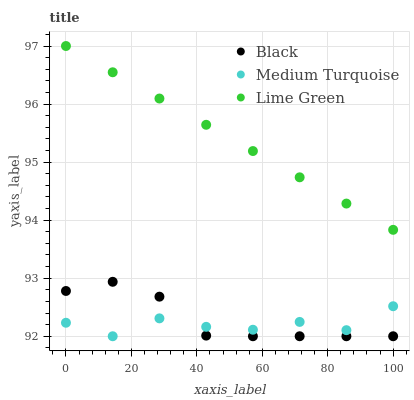Does Medium Turquoise have the minimum area under the curve?
Answer yes or no. Yes. Does Lime Green have the maximum area under the curve?
Answer yes or no. Yes. Does Black have the minimum area under the curve?
Answer yes or no. No. Does Black have the maximum area under the curve?
Answer yes or no. No. Is Lime Green the smoothest?
Answer yes or no. Yes. Is Medium Turquoise the roughest?
Answer yes or no. Yes. Is Black the smoothest?
Answer yes or no. No. Is Black the roughest?
Answer yes or no. No. Does Black have the lowest value?
Answer yes or no. Yes. Does Lime Green have the highest value?
Answer yes or no. Yes. Does Black have the highest value?
Answer yes or no. No. Is Black less than Lime Green?
Answer yes or no. Yes. Is Lime Green greater than Medium Turquoise?
Answer yes or no. Yes. Does Medium Turquoise intersect Black?
Answer yes or no. Yes. Is Medium Turquoise less than Black?
Answer yes or no. No. Is Medium Turquoise greater than Black?
Answer yes or no. No. Does Black intersect Lime Green?
Answer yes or no. No. 